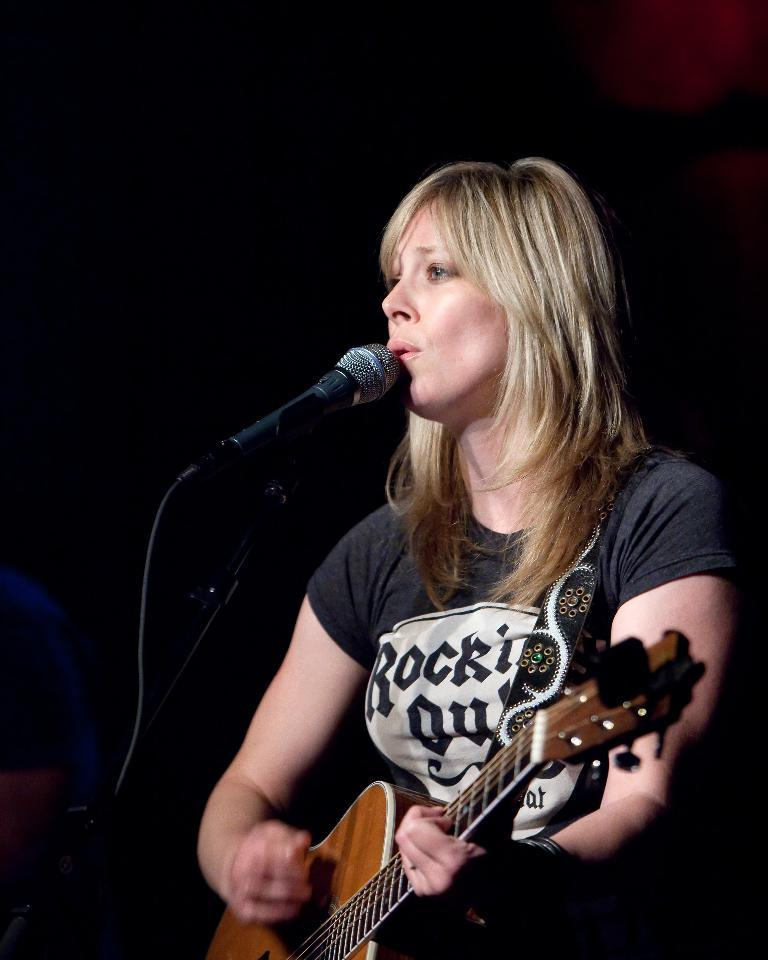What is the woman in the image doing? The woman is playing a guitar and singing. What object is the woman using to amplify her voice? There is a microphone in the image. How is the microphone positioned in the image? There is a mic holder in the image. What type of stretch can be seen on the woman's face in the image? There is no stretch visible on the woman's face in the image. Can you see a hammer or tank in the image? No, there is no hammer or tank present in the image. 